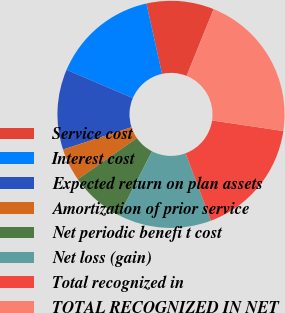Convert chart. <chart><loc_0><loc_0><loc_500><loc_500><pie_chart><fcel>Service cost<fcel>Interest cost<fcel>Expected return on plan assets<fcel>Amortization of prior service<fcel>Net periodic benefi t cost<fcel>Net loss (gain)<fcel>Total recognized in<fcel>TOTAL RECOGNIZED IN NET<nl><fcel>9.59%<fcel>15.11%<fcel>11.43%<fcel>4.68%<fcel>7.76%<fcel>13.27%<fcel>16.94%<fcel>21.22%<nl></chart> 